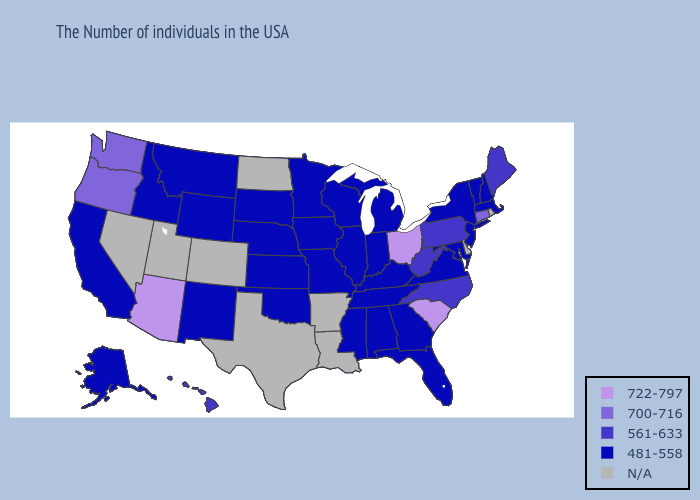Among the states that border Colorado , which have the highest value?
Answer briefly. Arizona. What is the highest value in the Northeast ?
Quick response, please. 700-716. What is the highest value in states that border Texas?
Concise answer only. 481-558. Name the states that have a value in the range N/A?
Be succinct. Rhode Island, Delaware, Louisiana, Arkansas, Texas, North Dakota, Colorado, Utah, Nevada. Name the states that have a value in the range 481-558?
Concise answer only. Massachusetts, New Hampshire, Vermont, New York, New Jersey, Maryland, Virginia, Florida, Georgia, Michigan, Kentucky, Indiana, Alabama, Tennessee, Wisconsin, Illinois, Mississippi, Missouri, Minnesota, Iowa, Kansas, Nebraska, Oklahoma, South Dakota, Wyoming, New Mexico, Montana, Idaho, California, Alaska. What is the value of Louisiana?
Quick response, please. N/A. Does Arizona have the highest value in the USA?
Concise answer only. Yes. Which states have the highest value in the USA?
Give a very brief answer. South Carolina, Ohio, Arizona. Does New Mexico have the lowest value in the USA?
Quick response, please. Yes. What is the value of Oregon?
Keep it brief. 700-716. What is the value of Colorado?
Write a very short answer. N/A. Name the states that have a value in the range 722-797?
Be succinct. South Carolina, Ohio, Arizona. 